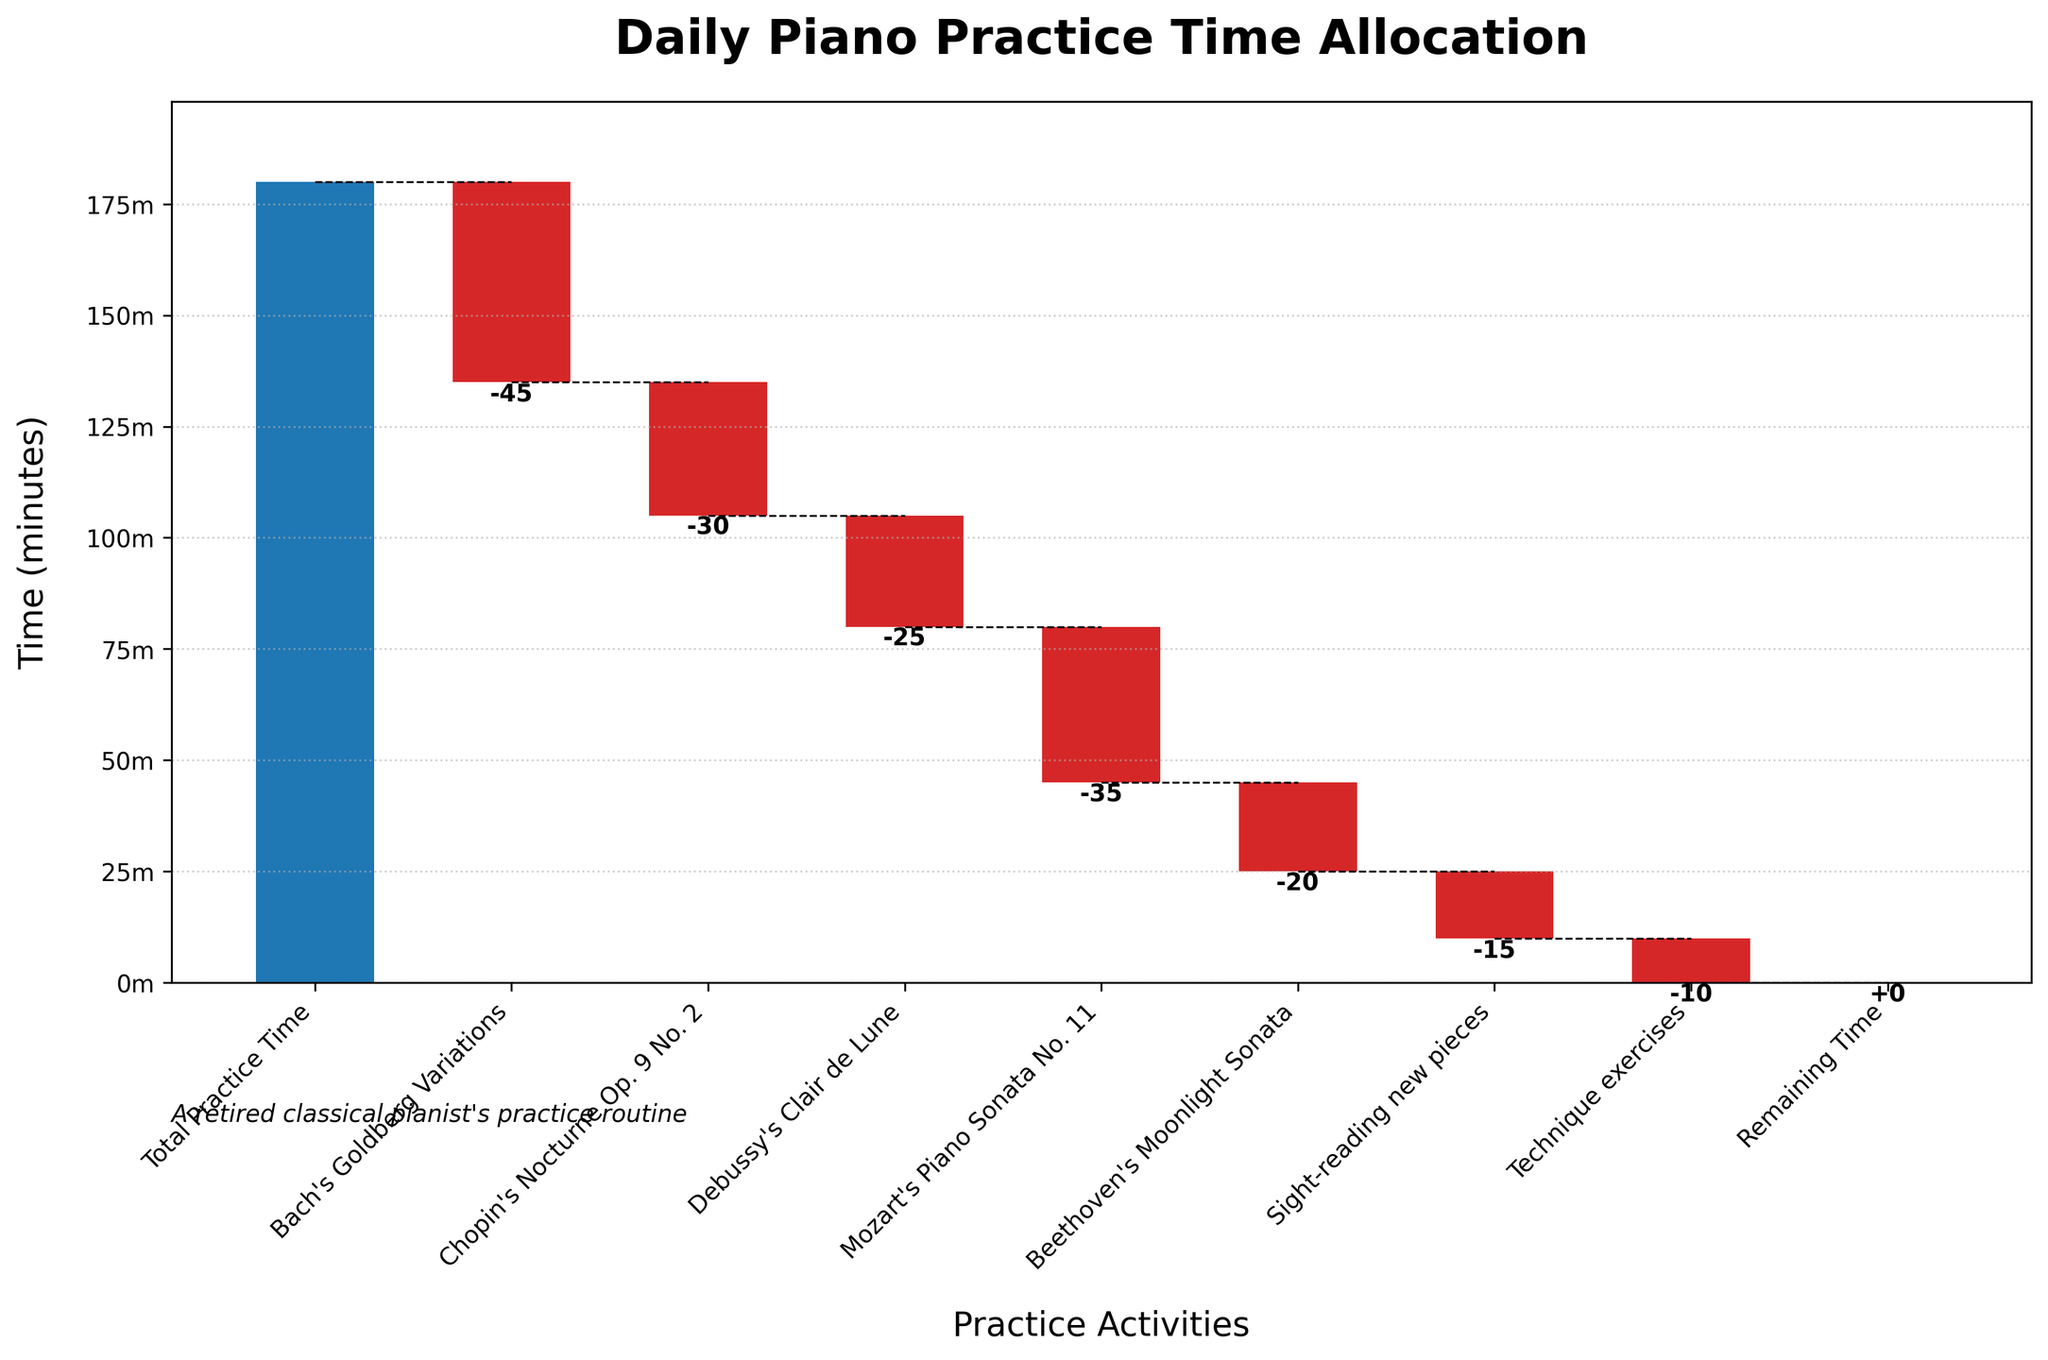what’s the total daily practice time? The title of the chart indicates "Daily Piano Practice Time Allocation", and the first bar labeled "Total Practice Time" shows the total daily practice time.
Answer: 180 minutes Which piano piece requires the most practice time? Bach's Goldberg Variations bar deducts 45 minutes from the total, which is the longest individual time allocation among all pieces.
Answer: Bach's Goldberg Variations How much time is allocated for sight-reading new pieces and technique exercises together? The chart shows -15 minutes for sight-reading new pieces and -10 minutes for technique exercises. Adding these gives -15 + -10 = -25 minutes.
Answer: 25 minutes What is the remaining time after all practice activities? The last bar in the chart is labeled "Remaining Time" with a value of 0, indicating that all practice time has been allocated.
Answer: 0 minutes How does the practice time of Debussy's Clair de Lune compare to Mozart's Piano Sonata No. 11? Debussy's Clair de Lune has -25 minutes and Mozart's Piano Sonata No. 11 has -35 minutes. Comparing these values, -25 is greater than -35.
Answer: Debussy's Clair de Lune takes less time What’s the cumulative practice time after practicing Beethoven’s Moonlight Sonata? The cumulative value reaches different levels after each practice activity. After practicing Beethoven’s Moonlight Sonata, the cumulative time reaches 180 - 45 (Bach) - 30 (Chopin) - 25 (Debussy) - 35 (Mozart) - 20 (Beethoven) = 25 minutes.
Answer: 25 minutes Which piano piece has the smallest practice time? Beethoven's Moonlight Sonata is allocated -20 minutes, which is the smallest individual practice time among all pieces.
Answer: Beethoven's Moonlight Sonata What is the total practice time allocated to all musical pieces excluding sight-reading and technique exercises? Summing times for all musical pieces: 45 (Bach) + 30 (Chopin) + 25 (Debussy) + 35 (Mozart) + 20 (Beethoven) = 155 minutes.
Answer: 155 minutes How much more time is spent on Bach’s Goldberg Variations compared to Debussy’s Clair de Lune? The practice time for Bach’s Goldberg Variations is -45 minutes and for Debussy’s Clair de Lune is -25 minutes. The difference is -45 - (-25) = -20 minutes. So, 20 minutes more is spent on Bach's.
Answer: 20 minutes 